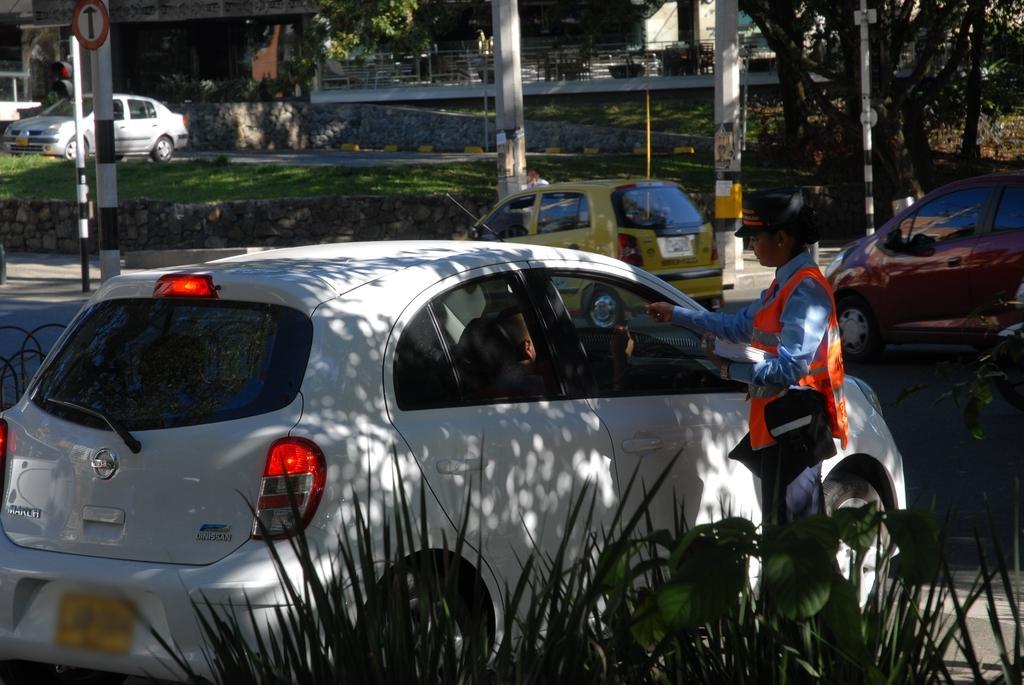Can you describe this image briefly? In this picture we can observe a white color car on the road. Beside the car there is a person standing, wearing orange color coat. We can observe yellow and maroon color cars here. There are poles in this picture. In the background we can observe some trees, railing and a wall. 